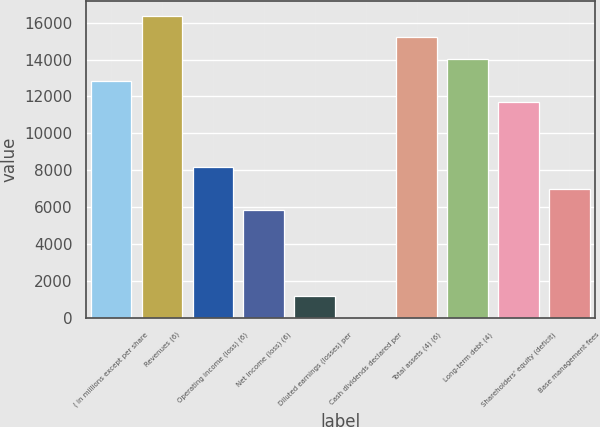Convert chart. <chart><loc_0><loc_0><loc_500><loc_500><bar_chart><fcel>( in millions except per share<fcel>Revenues (6)<fcel>Operating income (loss) (6)<fcel>Net income (loss) (6)<fcel>Diluted earnings (losses) per<fcel>Cash dividends declared per<fcel>Total assets (4) (6)<fcel>Long-term debt (4)<fcel>Shareholders' equity (deficit)<fcel>Base management fees<nl><fcel>12860.1<fcel>16367.3<fcel>8183.77<fcel>5845.61<fcel>1169.29<fcel>0.21<fcel>15198.2<fcel>14029.2<fcel>11691<fcel>7014.69<nl></chart> 